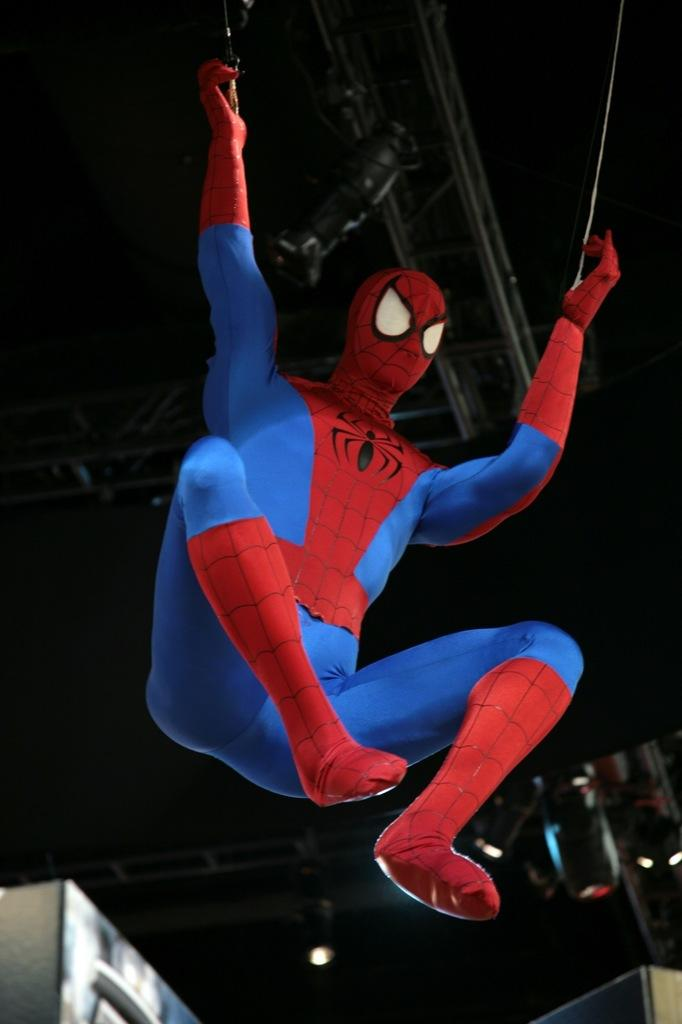What character is depicted in the image? There is a Spider-Man in the image. What color is the background of the image? The background of the image is black. What is the aftermath of the riddle in the image? There is no riddle or aftermath present in the image; it features Spider-Man against a black background. 